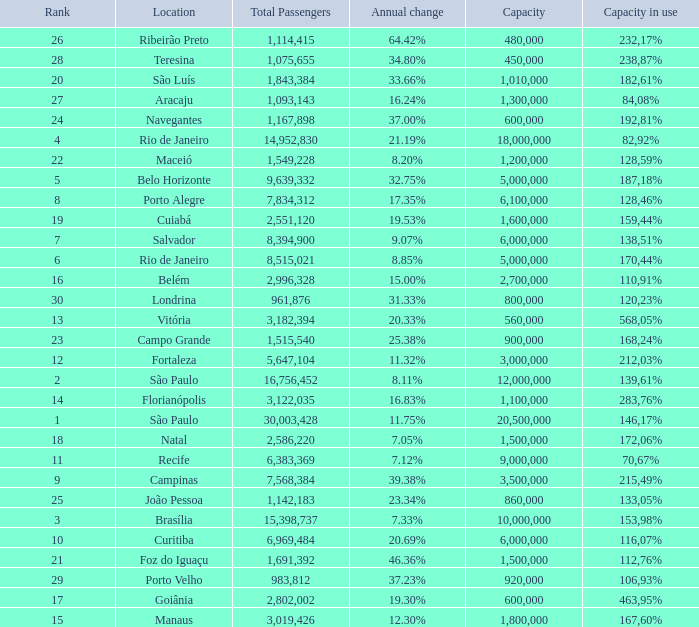Which location has a capacity that has a rank of 23? 168,24%. 